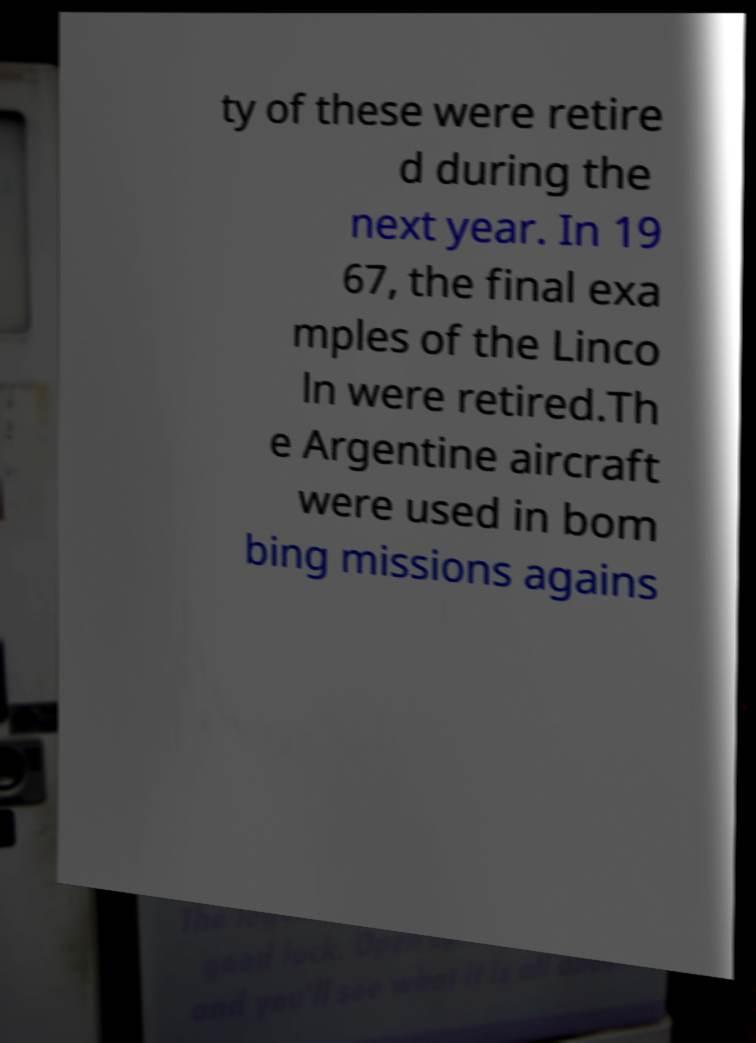Can you accurately transcribe the text from the provided image for me? ty of these were retire d during the next year. In 19 67, the final exa mples of the Linco ln were retired.Th e Argentine aircraft were used in bom bing missions agains 